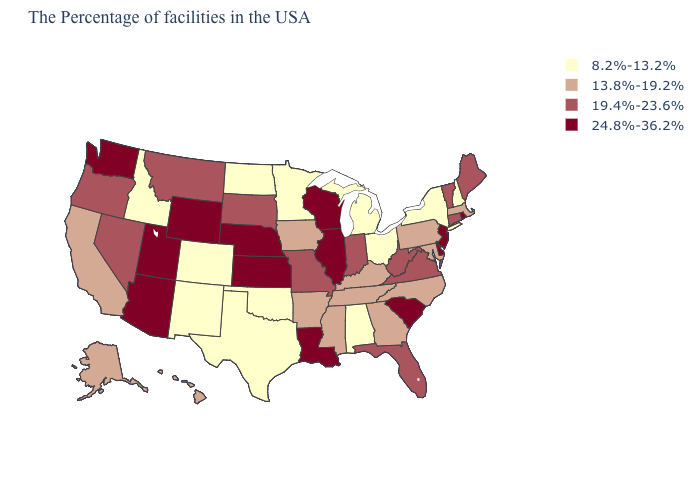Name the states that have a value in the range 24.8%-36.2%?
Short answer required. Rhode Island, New Jersey, Delaware, South Carolina, Wisconsin, Illinois, Louisiana, Kansas, Nebraska, Wyoming, Utah, Arizona, Washington. What is the value of Delaware?
Answer briefly. 24.8%-36.2%. Is the legend a continuous bar?
Short answer required. No. What is the highest value in the USA?
Short answer required. 24.8%-36.2%. Is the legend a continuous bar?
Short answer required. No. Among the states that border New Mexico , which have the highest value?
Keep it brief. Utah, Arizona. Does Pennsylvania have the same value as Delaware?
Quick response, please. No. Which states have the lowest value in the MidWest?
Be succinct. Ohio, Michigan, Minnesota, North Dakota. Name the states that have a value in the range 19.4%-23.6%?
Keep it brief. Maine, Vermont, Connecticut, Virginia, West Virginia, Florida, Indiana, Missouri, South Dakota, Montana, Nevada, Oregon. What is the value of North Dakota?
Keep it brief. 8.2%-13.2%. Among the states that border Arizona , which have the lowest value?
Quick response, please. Colorado, New Mexico. Which states have the highest value in the USA?
Write a very short answer. Rhode Island, New Jersey, Delaware, South Carolina, Wisconsin, Illinois, Louisiana, Kansas, Nebraska, Wyoming, Utah, Arizona, Washington. What is the value of Nevada?
Be succinct. 19.4%-23.6%. What is the value of Alaska?
Give a very brief answer. 13.8%-19.2%. Is the legend a continuous bar?
Answer briefly. No. 